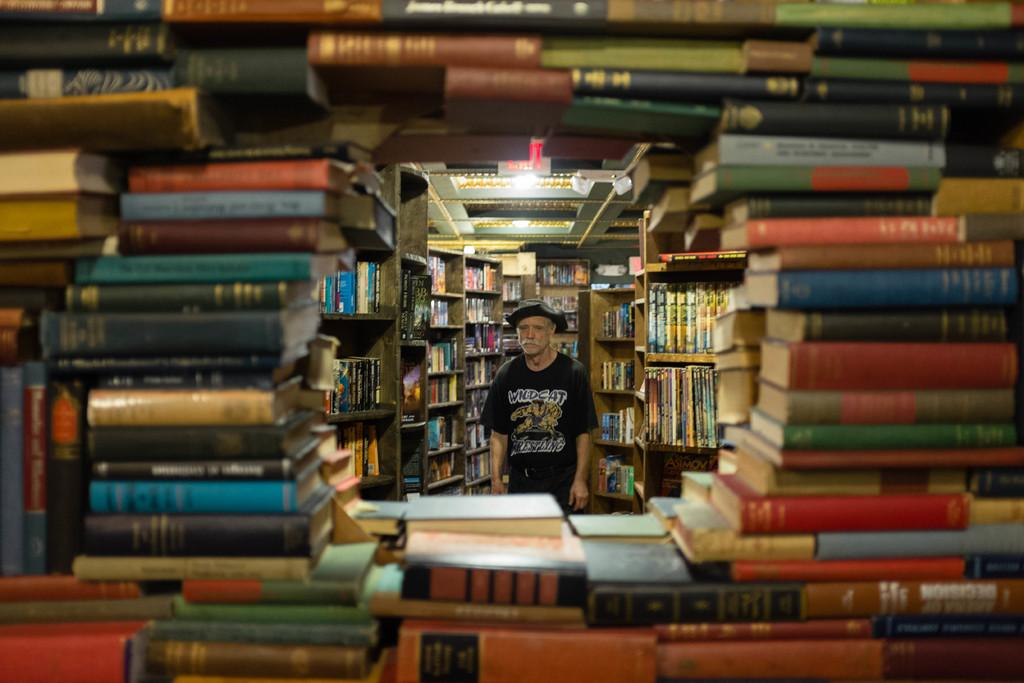What is the main subject of the image? There is a man standing in the image. Can you describe the man's clothing? The man is wearing a cap, a T-shirt, and trousers. What can be seen in the background of the image? There are books arranged in an order in the racks, and the location appears to be a library. What type of caption is written on the man's T-shirt in the image? There is no caption written on the man's T-shirt in the image. Can you tell me how many pencils the man is holding in the image? There is no pencil visible in the image, and the man is not holding anything. 